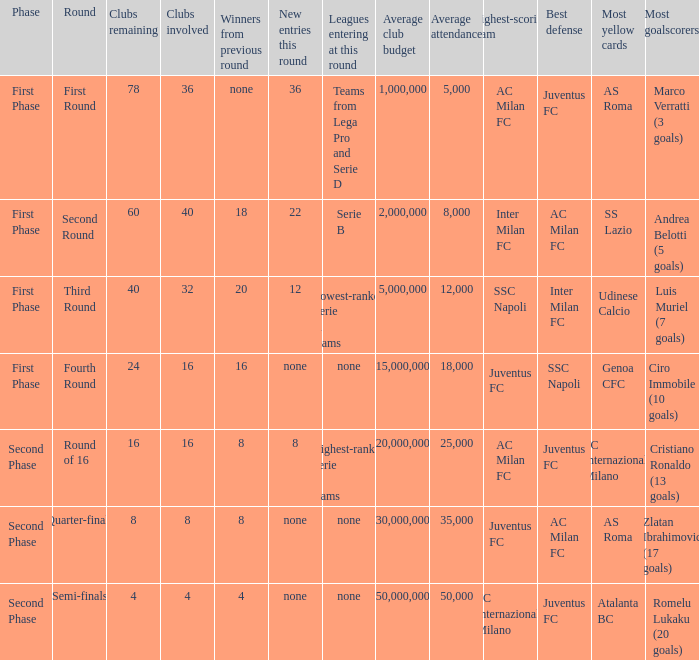Clubs involved is 8, what number would you find from winners from previous round? 8.0. 